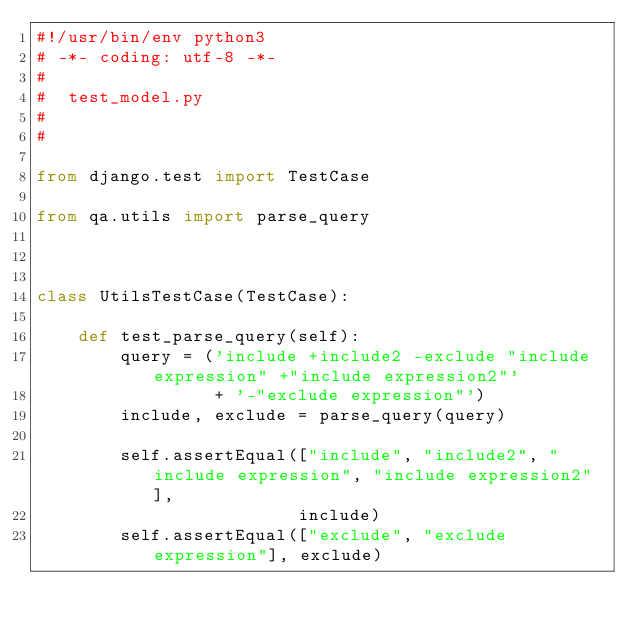<code> <loc_0><loc_0><loc_500><loc_500><_Python_>#!/usr/bin/env python3
# -*- coding: utf-8 -*-
#
#  test_model.py
#
#

from django.test import TestCase

from qa.utils import parse_query



class UtilsTestCase(TestCase):
    
    def test_parse_query(self):
        query = ('include +include2 -exclude "include expression" +"include expression2"'
                 + '-"exclude expression"')
        include, exclude = parse_query(query)
        
        self.assertEqual(["include", "include2", "include expression", "include expression2"],
                         include)
        self.assertEqual(["exclude", "exclude expression"], exclude)
</code> 